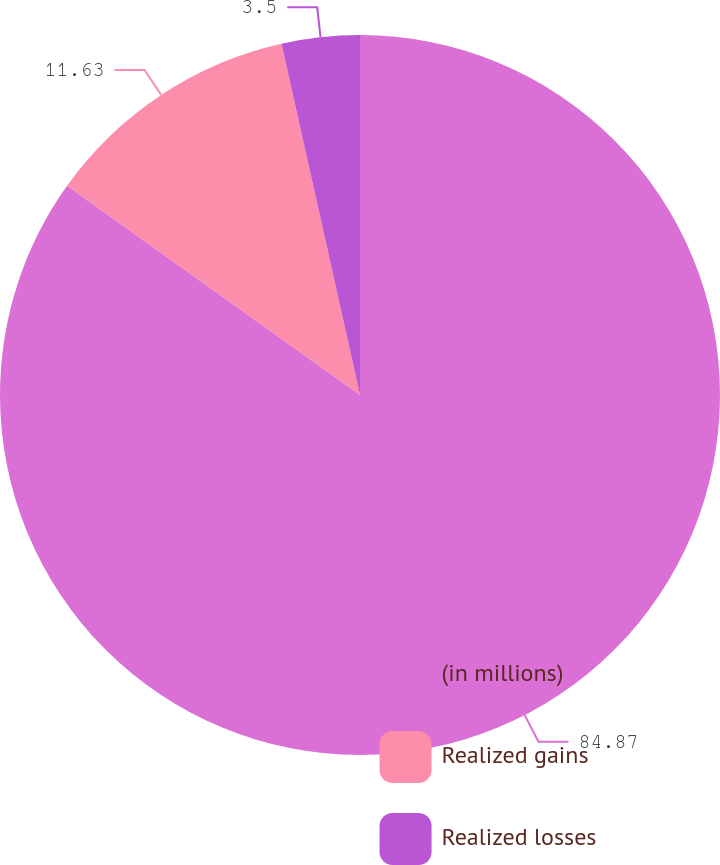Convert chart to OTSL. <chart><loc_0><loc_0><loc_500><loc_500><pie_chart><fcel>(in millions)<fcel>Realized gains<fcel>Realized losses<nl><fcel>84.87%<fcel>11.63%<fcel>3.5%<nl></chart> 